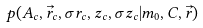Convert formula to latex. <formula><loc_0><loc_0><loc_500><loc_500>p ( A _ { c } , \vec { r } _ { c } , \sigma r _ { c } , z _ { c } , \sigma z _ { c } | { m _ { 0 } } , { C } , { \vec { r } } )</formula> 